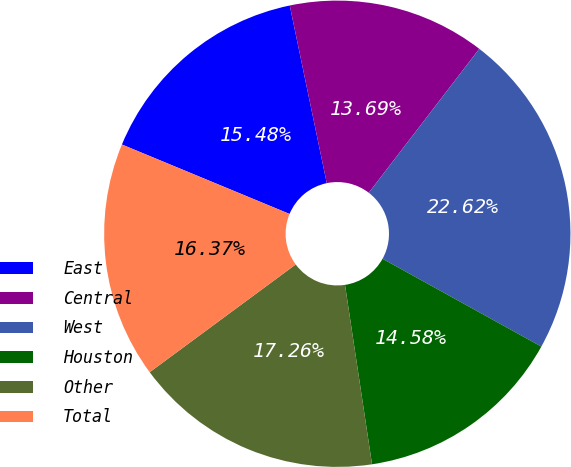Convert chart. <chart><loc_0><loc_0><loc_500><loc_500><pie_chart><fcel>East<fcel>Central<fcel>West<fcel>Houston<fcel>Other<fcel>Total<nl><fcel>15.48%<fcel>13.69%<fcel>22.62%<fcel>14.58%<fcel>17.26%<fcel>16.37%<nl></chart> 